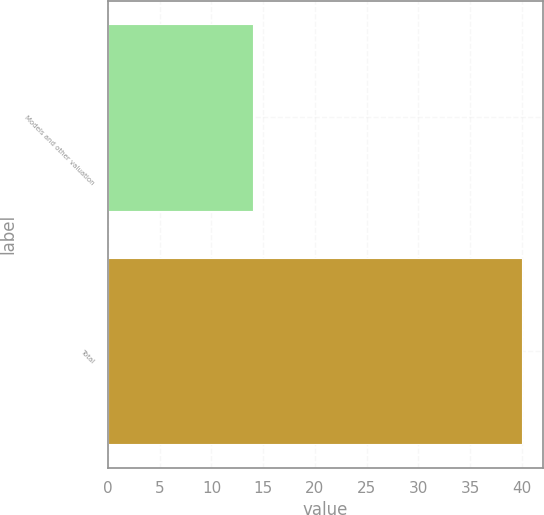Convert chart to OTSL. <chart><loc_0><loc_0><loc_500><loc_500><bar_chart><fcel>Models and other valuation<fcel>Total<nl><fcel>14<fcel>40<nl></chart> 